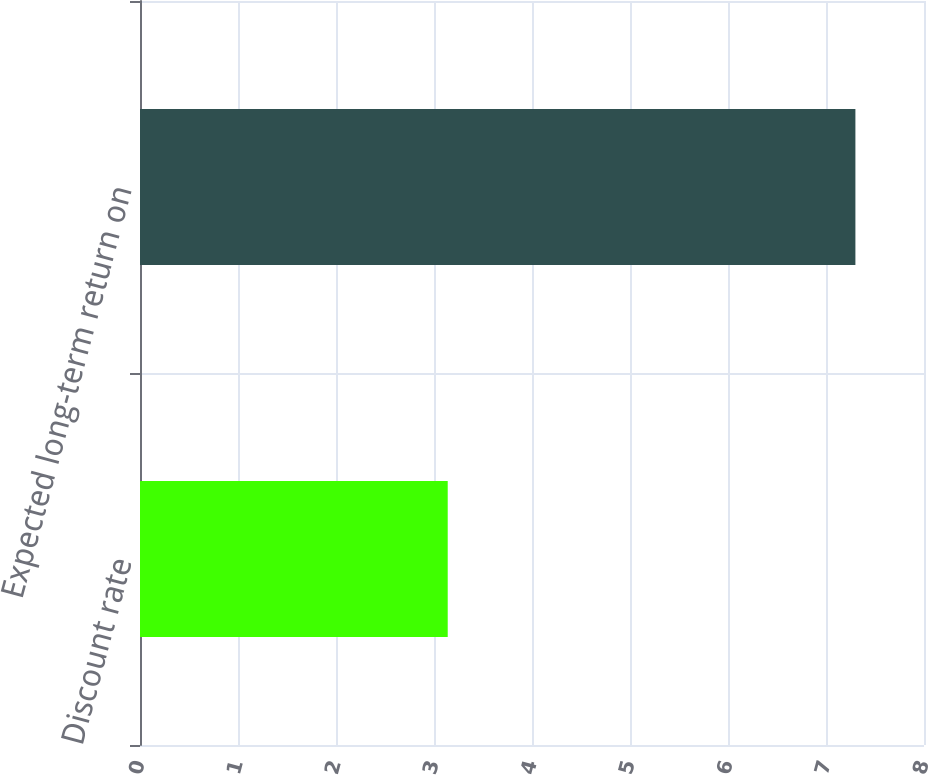<chart> <loc_0><loc_0><loc_500><loc_500><bar_chart><fcel>Discount rate<fcel>Expected long-term return on<nl><fcel>3.14<fcel>7.3<nl></chart> 